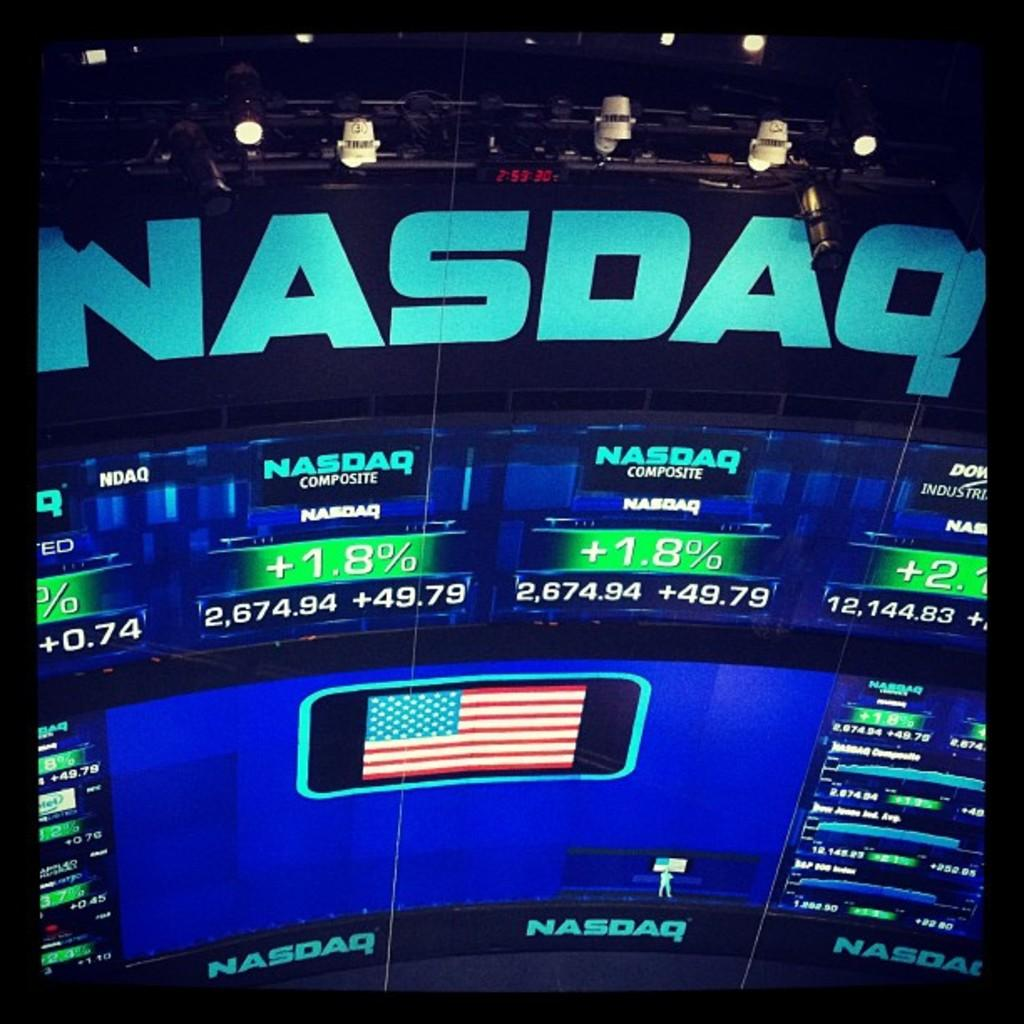What is the main object in the image? There is a screen in the image. What can be seen on the screen? The screen displays text and numbers. Are there any symbols on the screen? Yes, there is a flag symbol on the screen. What type of meal is being prepared in the image? There is no meal preparation visible in the image; it only shows a screen with text, numbers, and a flag symbol. Can you see a baby in the image? There is no baby present in the image; it only shows a screen with text, numbers, and a flag symbol. 